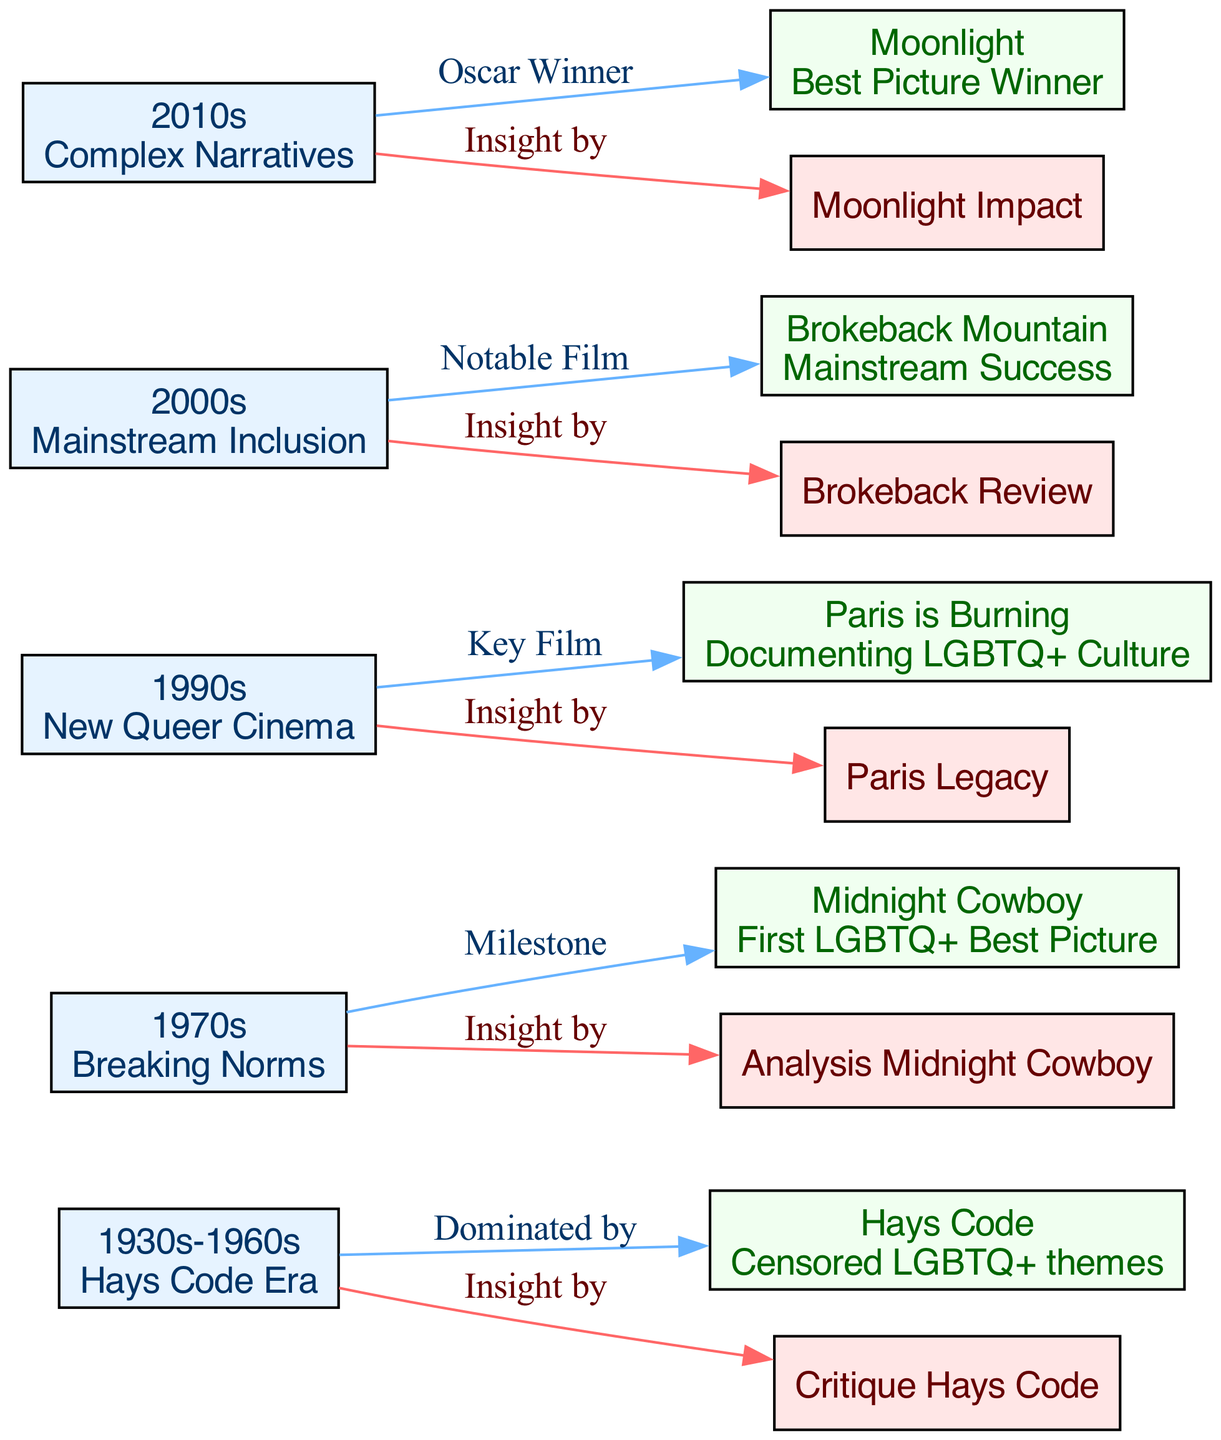What era does "Critique Hays Code" belong to? The node labeled "Critique Hays Code" is directly linked to "1930s-1960s," indicating that it is a critique associated with that era, specifically during the time dominated by the Hays Code.
Answer: 1930s-1960s What notable film is associated with the 2000s? The diagram connects "2000s" to "Brokeback Mountain," marking it as a notable film from that decade, reflecting its importance in LGBTQ+ representation.
Answer: Brokeback Mountain How many decades are represented in the diagram? The nodes specifically labeled with decades include "1930s-1960s," "1970s," "1990s," "2000s," and "2010s," totaling five distinct decades focused on the evolution of LGBTQ+ representation.
Answer: 5 Which film is described as the first LGBTQ+ Best Picture? The diagram identifies "Midnight Cowboy" as the first LGBTQ+ film to win the Best Picture award, drawing a direct line between the 1970s and this key film.
Answer: Midnight Cowboy Who provided insight on the film "Paris is Burning"? The diagram showcases an edge labeled "Insight by" connecting "1990s" to "Paris Legacy," indicating that Tre'vell Anderson offered insights on this film in relation to its cultural impact.
Answer: Tre'vell Anderson What is the significance of "Moonlight" in the 2010s? According to the edges in the diagram, "Moonlight" is linked to "2010s" with the label "Oscar Winner," signifying its critical role as a celebrated film during that decade within LGBTQ+ representation.
Answer: Oscar Winner What major milestone is associated with the 1970s? The diagram identifies "Midnight Cowboy" as a milestone film related to the 1970s, emphasizing its importance in breaking new ground for LGBTQ+ themes in cinema.
Answer: Milestone How many insights from Tre'vell Anderson are represented in the diagram? Counting the edges labeled "Insight by" in the diagram, there are five insights that reference Tre'vell Anderson's contributions to discussions surrounding different films over the decades.
Answer: 5 What relationship does "Paris is Burning" have with the 1990s? The edge labeled "Key Film" connecting "1990s" to "Paris is Burning" indicates that this film is recognized as a key example of LGBTQ+ representation during that decade.
Answer: Key Film 